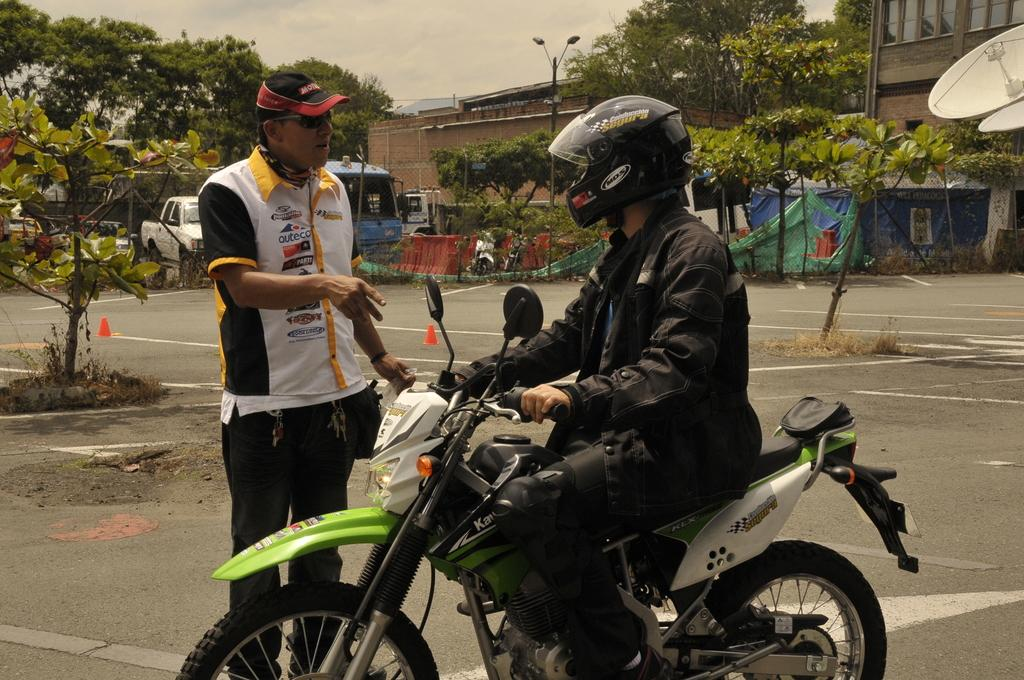What is the person sitting doing in the image? The person sitting is holding a bike. What safety gear is the person sitting wearing? The person sitting is wearing a helmet. What is the standing person wearing? The standing person is wearing a cap and glasses. What can be seen in the background of the image? There are buildings, lights, a pole, trees, and the sky visible in the background. What is moving in the background of the image? There are vehicles on the road in the background. What type of machine is being used to brew coffee in the image? There is no machine or coffee brewing activity present in the image. What type of cup is the person sitting holding in the image? The person sitting is holding a bike, not a cup. 